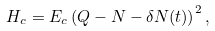Convert formula to latex. <formula><loc_0><loc_0><loc_500><loc_500>H _ { c } = E _ { c } \left ( Q - N - \delta N ( t ) \right ) ^ { 2 } ,</formula> 